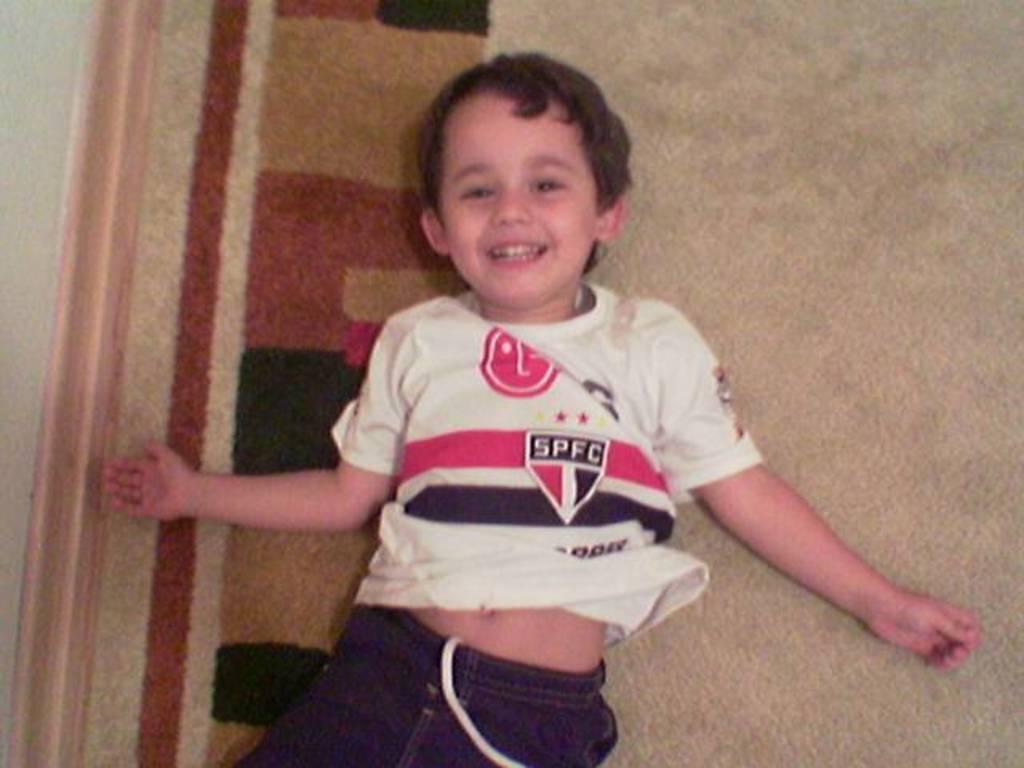What brand is the shirt sponser?
Give a very brief answer. Lg. 